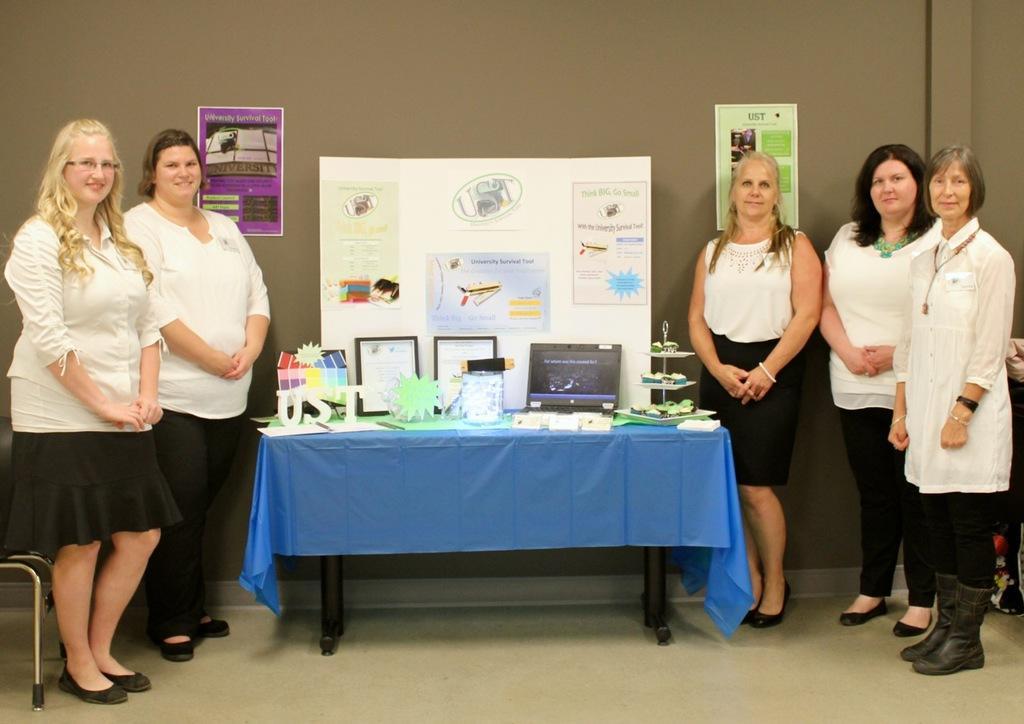In one or two sentences, can you explain what this image depicts? There are two women on the left and three women on the right and in between them there is a table on which frames,laptop,paper made things and on the wall we can see posters. 